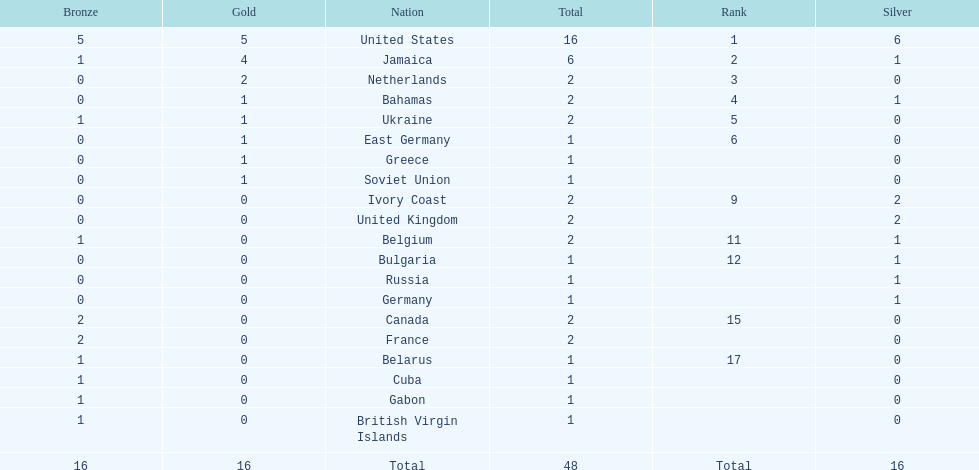What country won more gold medals than any other? United States. Parse the full table. {'header': ['Bronze', 'Gold', 'Nation', 'Total', 'Rank', 'Silver'], 'rows': [['5', '5', 'United States', '16', '1', '6'], ['1', '4', 'Jamaica', '6', '2', '1'], ['0', '2', 'Netherlands', '2', '3', '0'], ['0', '1', 'Bahamas', '2', '4', '1'], ['1', '1', 'Ukraine', '2', '5', '0'], ['0', '1', 'East Germany', '1', '6', '0'], ['0', '1', 'Greece', '1', '', '0'], ['0', '1', 'Soviet Union', '1', '', '0'], ['0', '0', 'Ivory Coast', '2', '9', '2'], ['0', '0', 'United Kingdom', '2', '', '2'], ['1', '0', 'Belgium', '2', '11', '1'], ['0', '0', 'Bulgaria', '1', '12', '1'], ['0', '0', 'Russia', '1', '', '1'], ['0', '0', 'Germany', '1', '', '1'], ['2', '0', 'Canada', '2', '15', '0'], ['2', '0', 'France', '2', '', '0'], ['1', '0', 'Belarus', '1', '17', '0'], ['1', '0', 'Cuba', '1', '', '0'], ['1', '0', 'Gabon', '1', '', '0'], ['1', '0', 'British Virgin Islands', '1', '', '0'], ['16', '16', 'Total', '48', 'Total', '16']]} 